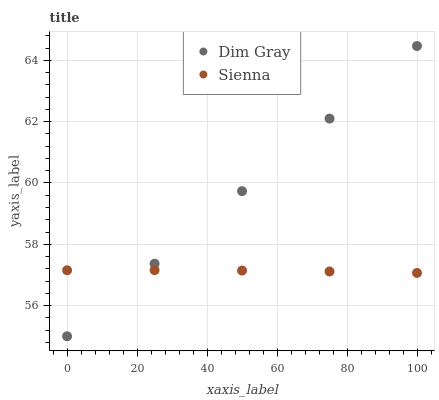Does Sienna have the minimum area under the curve?
Answer yes or no. Yes. Does Dim Gray have the maximum area under the curve?
Answer yes or no. Yes. Does Dim Gray have the minimum area under the curve?
Answer yes or no. No. Is Dim Gray the smoothest?
Answer yes or no. Yes. Is Sienna the roughest?
Answer yes or no. Yes. Is Dim Gray the roughest?
Answer yes or no. No. Does Dim Gray have the lowest value?
Answer yes or no. Yes. Does Dim Gray have the highest value?
Answer yes or no. Yes. Does Sienna intersect Dim Gray?
Answer yes or no. Yes. Is Sienna less than Dim Gray?
Answer yes or no. No. Is Sienna greater than Dim Gray?
Answer yes or no. No. 